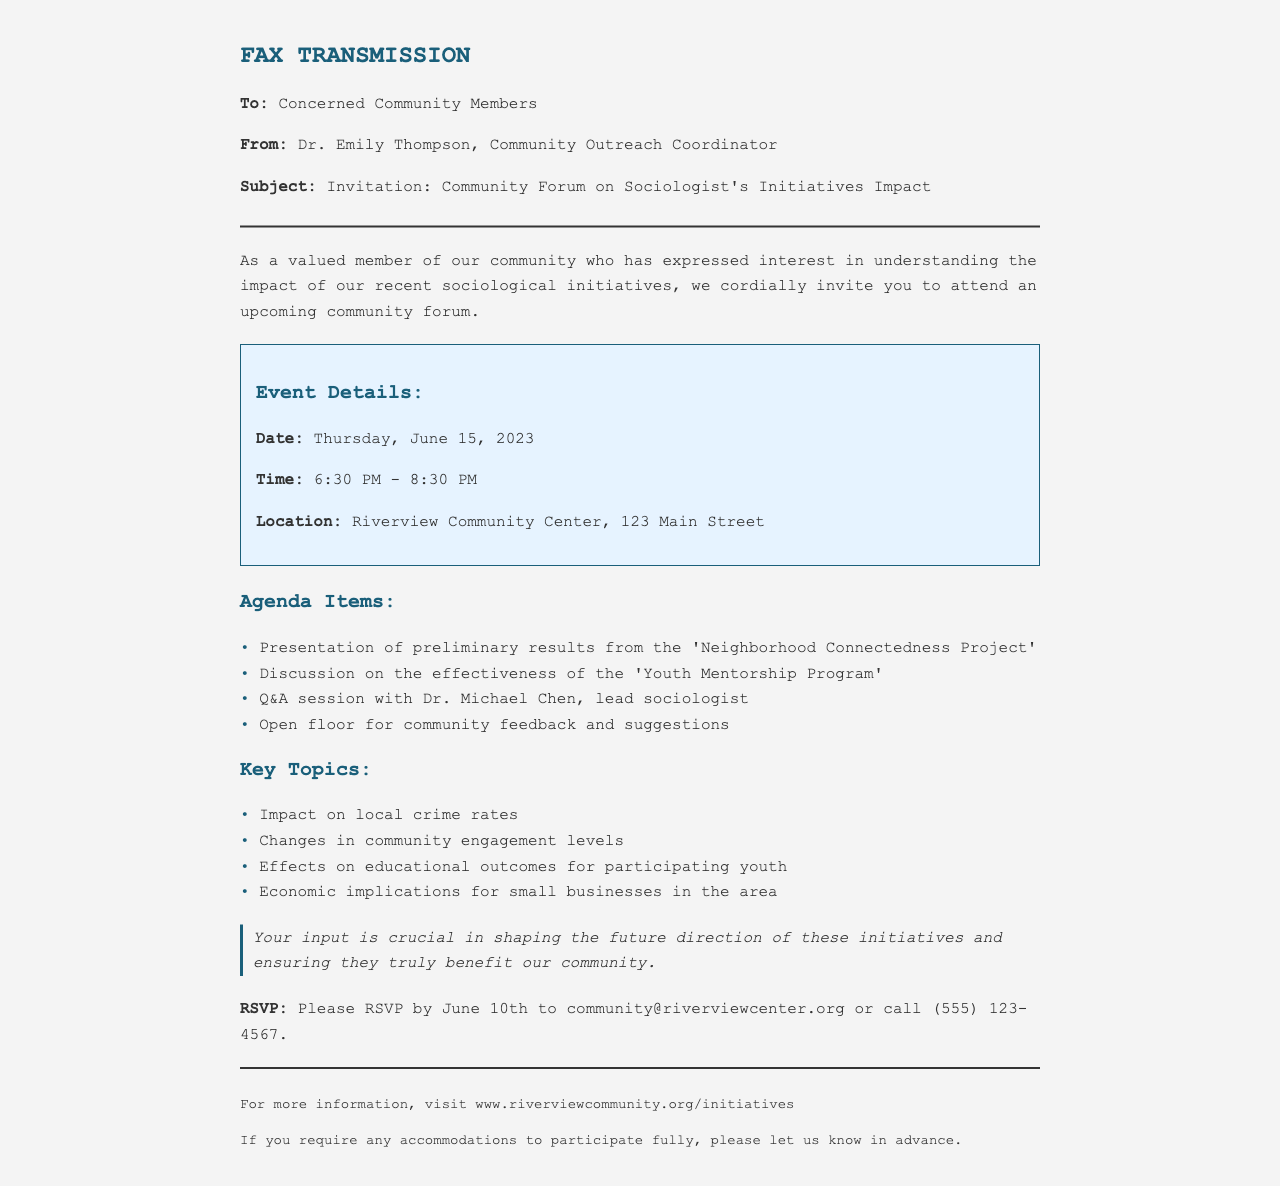What is the date of the community forum? The date is specified in the event details section of the document as Thursday, June 15, 2023.
Answer: Thursday, June 15, 2023 What time does the community forum start? The start time is included in the event details of the document, which states 6:30 PM.
Answer: 6:30 PM Who is the lead sociologist for the Q&A session? The lead sociologist's name is mentioned in the agenda items under the Q&A session, which states Dr. Michael Chen.
Answer: Dr. Michael Chen What is the location of the event? The location is clearly stated in the event details section as Riverview Community Center, 123 Main Street.
Answer: Riverview Community Center, 123 Main Street What is one of the key topics to be discussed? The document includes a list of key topics, one of which is the impact on local crime rates.
Answer: Impact on local crime rates What is the deadline for RSVPing? The RSVP deadline is provided in a specific line in the document, which indicates June 10th.
Answer: June 10th What is the email for RSVPing? The email address for RSVPing is outlined in the RSVP section and is community@riverviewcenter.org.
Answer: community@riverviewcenter.org Why is community input emphasized in the document? The importance of community input is highlighted in a designated section, indicating it shapes the future of the initiatives.
Answer: Shaping future direction What type of event is being held? The document specifies that it is a community forum, which is mentioned in both the invitation and the subject line.
Answer: Community forum 